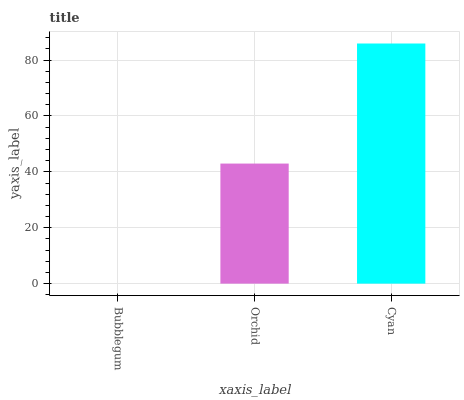Is Bubblegum the minimum?
Answer yes or no. Yes. Is Cyan the maximum?
Answer yes or no. Yes. Is Orchid the minimum?
Answer yes or no. No. Is Orchid the maximum?
Answer yes or no. No. Is Orchid greater than Bubblegum?
Answer yes or no. Yes. Is Bubblegum less than Orchid?
Answer yes or no. Yes. Is Bubblegum greater than Orchid?
Answer yes or no. No. Is Orchid less than Bubblegum?
Answer yes or no. No. Is Orchid the high median?
Answer yes or no. Yes. Is Orchid the low median?
Answer yes or no. Yes. Is Bubblegum the high median?
Answer yes or no. No. Is Cyan the low median?
Answer yes or no. No. 